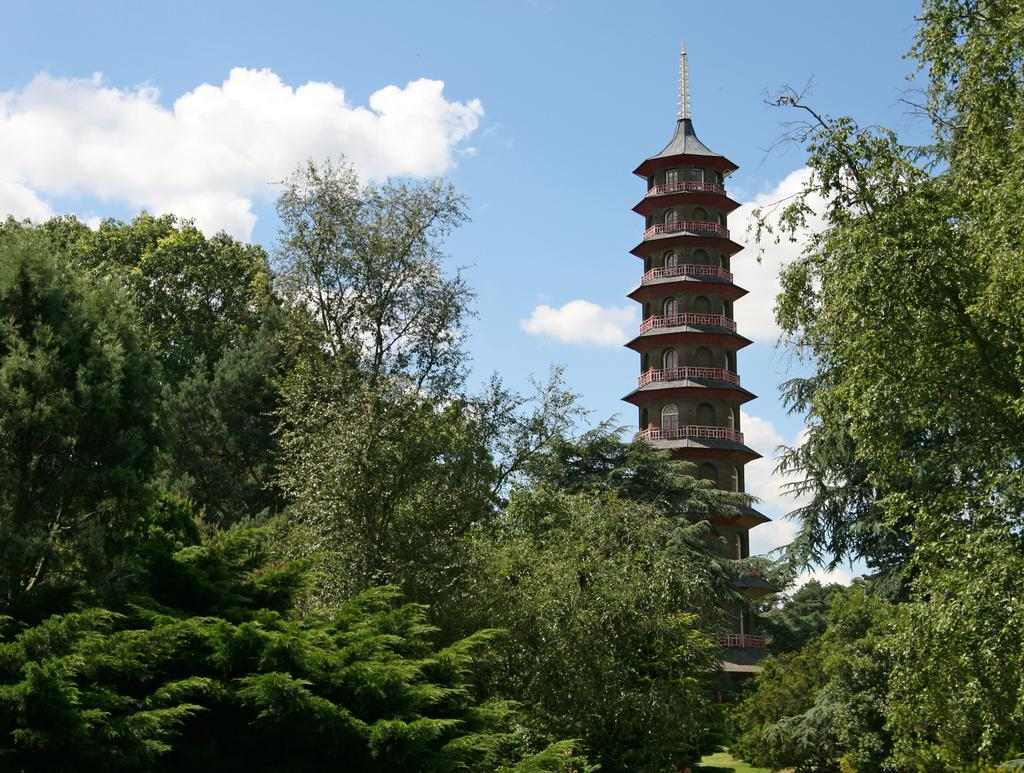What type of vegetation can be seen in the image? There are trees in the image. What structure is visible in the background of the image? There is a tower in the background of the image. How would you describe the sky in the image? The sky is cloudy in the image. Can you tell me how many actors are sitting on the cushion in the image? There are no actors or cushions present in the image; it features trees and a tower with a cloudy sky. 